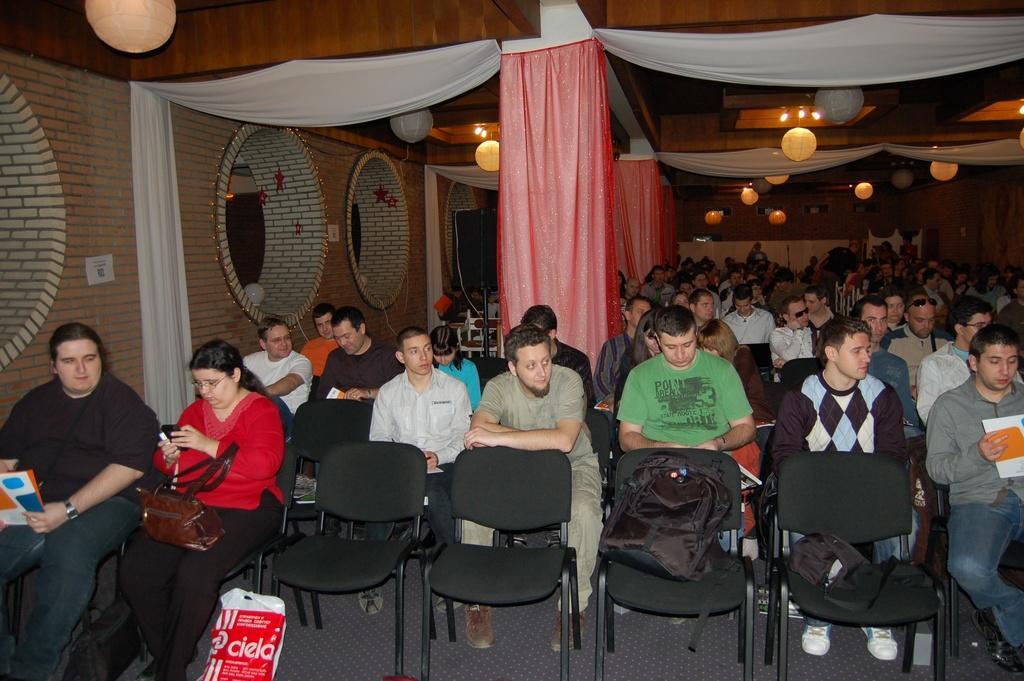Can you describe this image briefly? In this image I can see a crow is sitting on the chairs. In the background I can see a wall, pillars, curtains and lights. This image is taken may be in a hall. 